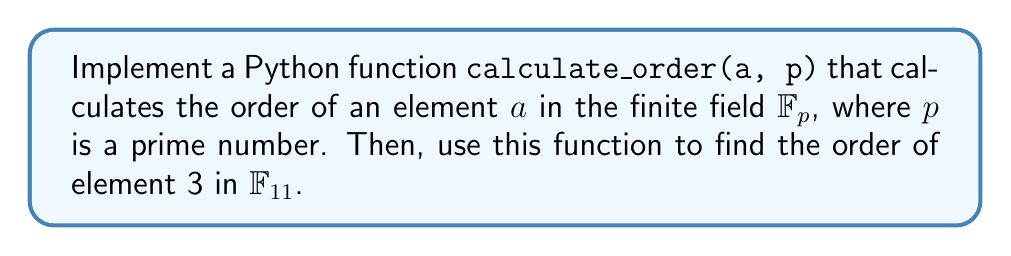Provide a solution to this math problem. To solve this problem, we'll follow these steps:

1. Implement the `calculate_order` function:
   a. Define the function with parameters `a` and `p`.
   b. Use a loop to iterate through possible orders.
   c. Use modular exponentiation to check if $a^k \equiv 1 \pmod{p}$.
   d. Return the smallest $k$ that satisfies the condition.

2. Use the function to calculate the order of 3 in $\mathbb{F}_{11}$.

Here's the Python implementation:

```python
def calculate_order(a, p):
    if a == 0:
        return float('inf')
    for k in range(1, p):
        if pow(a, k, p) == 1:
            return k
    return p - 1

# Calculate the order of 3 in F_11
result = calculate_order(3, 11)
print(f"The order of 3 in F_11 is: {result}")
```

Explanation of the `calculate_order` function:
- We first check if `a` is 0, which has infinite order.
- We iterate through possible orders from 1 to p-1.
- We use `pow(a, k, p)` for efficient modular exponentiation.
- We return the smallest k that satisfies $a^k \equiv 1 \pmod{p}$.
- If no k is found, we return p-1 (the maximum possible order).

To understand why the order of 3 in $\mathbb{F}_{11}$ is 5, let's calculate the powers of 3 modulo 11:

$3^1 \equiv 3 \pmod{11}$
$3^2 \equiv 9 \pmod{11}$
$3^3 \equiv 5 \pmod{11}$
$3^4 \equiv 4 \pmod{11}$
$3^5 \equiv 1 \pmod{11}$

Thus, the smallest positive integer $k$ such that $3^k \equiv 1 \pmod{11}$ is 5.
Answer: 5 